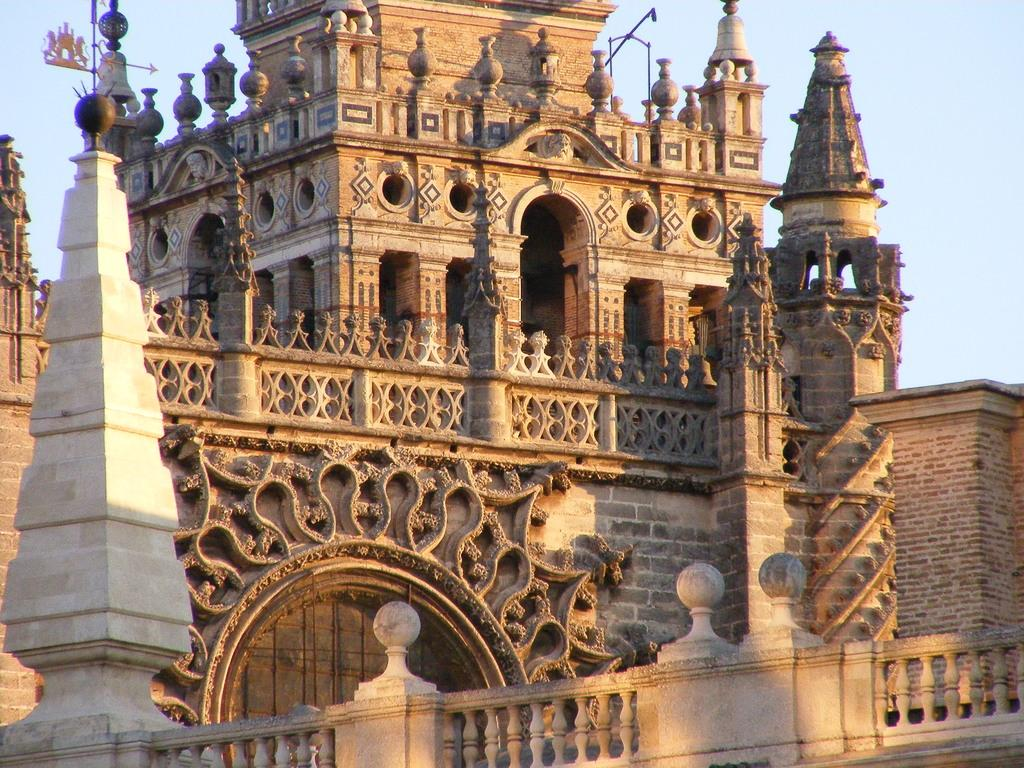What type of structure is the main subject of the image? There is a castle in the image. What type of bells can be heard ringing in the image? There are no bells present in the image, as it only features a castle. 